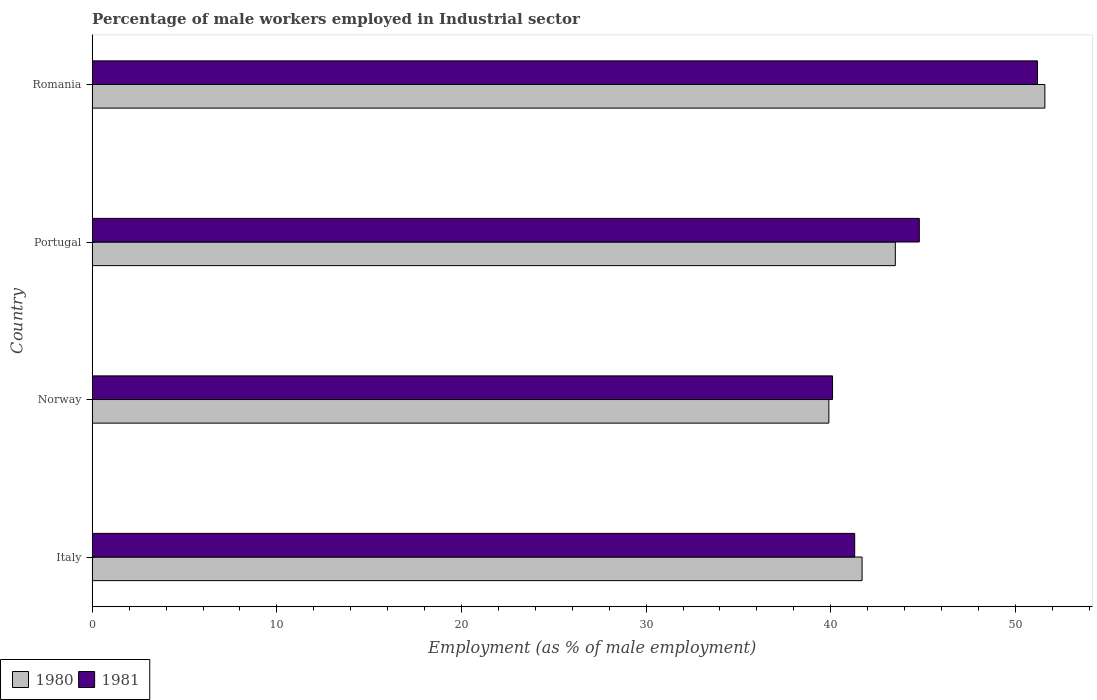How many bars are there on the 1st tick from the top?
Keep it short and to the point. 2. How many bars are there on the 4th tick from the bottom?
Give a very brief answer. 2. What is the label of the 2nd group of bars from the top?
Your response must be concise. Portugal. In how many cases, is the number of bars for a given country not equal to the number of legend labels?
Provide a short and direct response. 0. What is the percentage of male workers employed in Industrial sector in 1981 in Italy?
Your response must be concise. 41.3. Across all countries, what is the maximum percentage of male workers employed in Industrial sector in 1981?
Your answer should be compact. 51.2. Across all countries, what is the minimum percentage of male workers employed in Industrial sector in 1981?
Keep it short and to the point. 40.1. In which country was the percentage of male workers employed in Industrial sector in 1981 maximum?
Offer a terse response. Romania. In which country was the percentage of male workers employed in Industrial sector in 1980 minimum?
Provide a succinct answer. Norway. What is the total percentage of male workers employed in Industrial sector in 1980 in the graph?
Offer a very short reply. 176.7. What is the difference between the percentage of male workers employed in Industrial sector in 1981 in Portugal and that in Romania?
Your answer should be compact. -6.4. What is the average percentage of male workers employed in Industrial sector in 1981 per country?
Your response must be concise. 44.35. What is the difference between the percentage of male workers employed in Industrial sector in 1980 and percentage of male workers employed in Industrial sector in 1981 in Italy?
Provide a short and direct response. 0.4. In how many countries, is the percentage of male workers employed in Industrial sector in 1981 greater than 16 %?
Your answer should be very brief. 4. What is the ratio of the percentage of male workers employed in Industrial sector in 1981 in Italy to that in Romania?
Ensure brevity in your answer.  0.81. Is the percentage of male workers employed in Industrial sector in 1981 in Norway less than that in Romania?
Provide a short and direct response. Yes. What is the difference between the highest and the second highest percentage of male workers employed in Industrial sector in 1980?
Ensure brevity in your answer.  8.1. What is the difference between the highest and the lowest percentage of male workers employed in Industrial sector in 1981?
Your response must be concise. 11.1. Is the sum of the percentage of male workers employed in Industrial sector in 1981 in Norway and Romania greater than the maximum percentage of male workers employed in Industrial sector in 1980 across all countries?
Your answer should be very brief. Yes. What does the 2nd bar from the top in Portugal represents?
Your answer should be very brief. 1980. How many bars are there?
Provide a short and direct response. 8. What is the difference between two consecutive major ticks on the X-axis?
Keep it short and to the point. 10. Are the values on the major ticks of X-axis written in scientific E-notation?
Offer a terse response. No. Where does the legend appear in the graph?
Ensure brevity in your answer.  Bottom left. How many legend labels are there?
Your response must be concise. 2. What is the title of the graph?
Offer a very short reply. Percentage of male workers employed in Industrial sector. What is the label or title of the X-axis?
Ensure brevity in your answer.  Employment (as % of male employment). What is the label or title of the Y-axis?
Provide a short and direct response. Country. What is the Employment (as % of male employment) in 1980 in Italy?
Your response must be concise. 41.7. What is the Employment (as % of male employment) of 1981 in Italy?
Provide a short and direct response. 41.3. What is the Employment (as % of male employment) in 1980 in Norway?
Your answer should be very brief. 39.9. What is the Employment (as % of male employment) of 1981 in Norway?
Give a very brief answer. 40.1. What is the Employment (as % of male employment) of 1980 in Portugal?
Make the answer very short. 43.5. What is the Employment (as % of male employment) of 1981 in Portugal?
Give a very brief answer. 44.8. What is the Employment (as % of male employment) in 1980 in Romania?
Your response must be concise. 51.6. What is the Employment (as % of male employment) of 1981 in Romania?
Make the answer very short. 51.2. Across all countries, what is the maximum Employment (as % of male employment) in 1980?
Give a very brief answer. 51.6. Across all countries, what is the maximum Employment (as % of male employment) in 1981?
Provide a succinct answer. 51.2. Across all countries, what is the minimum Employment (as % of male employment) in 1980?
Offer a terse response. 39.9. Across all countries, what is the minimum Employment (as % of male employment) in 1981?
Offer a very short reply. 40.1. What is the total Employment (as % of male employment) in 1980 in the graph?
Keep it short and to the point. 176.7. What is the total Employment (as % of male employment) of 1981 in the graph?
Offer a very short reply. 177.4. What is the difference between the Employment (as % of male employment) in 1980 in Italy and that in Portugal?
Your response must be concise. -1.8. What is the difference between the Employment (as % of male employment) in 1980 in Italy and that in Romania?
Your answer should be very brief. -9.9. What is the difference between the Employment (as % of male employment) in 1980 in Norway and that in Portugal?
Keep it short and to the point. -3.6. What is the difference between the Employment (as % of male employment) of 1981 in Norway and that in Romania?
Offer a terse response. -11.1. What is the difference between the Employment (as % of male employment) in 1980 in Italy and the Employment (as % of male employment) in 1981 in Portugal?
Your answer should be very brief. -3.1. What is the difference between the Employment (as % of male employment) in 1980 in Norway and the Employment (as % of male employment) in 1981 in Portugal?
Give a very brief answer. -4.9. What is the difference between the Employment (as % of male employment) in 1980 in Portugal and the Employment (as % of male employment) in 1981 in Romania?
Your answer should be compact. -7.7. What is the average Employment (as % of male employment) of 1980 per country?
Your response must be concise. 44.17. What is the average Employment (as % of male employment) in 1981 per country?
Offer a very short reply. 44.35. What is the difference between the Employment (as % of male employment) of 1980 and Employment (as % of male employment) of 1981 in Italy?
Keep it short and to the point. 0.4. What is the difference between the Employment (as % of male employment) in 1980 and Employment (as % of male employment) in 1981 in Romania?
Your answer should be compact. 0.4. What is the ratio of the Employment (as % of male employment) in 1980 in Italy to that in Norway?
Provide a short and direct response. 1.05. What is the ratio of the Employment (as % of male employment) in 1981 in Italy to that in Norway?
Provide a short and direct response. 1.03. What is the ratio of the Employment (as % of male employment) of 1980 in Italy to that in Portugal?
Keep it short and to the point. 0.96. What is the ratio of the Employment (as % of male employment) of 1981 in Italy to that in Portugal?
Offer a very short reply. 0.92. What is the ratio of the Employment (as % of male employment) of 1980 in Italy to that in Romania?
Offer a terse response. 0.81. What is the ratio of the Employment (as % of male employment) in 1981 in Italy to that in Romania?
Provide a short and direct response. 0.81. What is the ratio of the Employment (as % of male employment) of 1980 in Norway to that in Portugal?
Give a very brief answer. 0.92. What is the ratio of the Employment (as % of male employment) of 1981 in Norway to that in Portugal?
Ensure brevity in your answer.  0.9. What is the ratio of the Employment (as % of male employment) of 1980 in Norway to that in Romania?
Make the answer very short. 0.77. What is the ratio of the Employment (as % of male employment) in 1981 in Norway to that in Romania?
Offer a terse response. 0.78. What is the ratio of the Employment (as % of male employment) in 1980 in Portugal to that in Romania?
Make the answer very short. 0.84. What is the ratio of the Employment (as % of male employment) in 1981 in Portugal to that in Romania?
Offer a very short reply. 0.88. What is the difference between the highest and the second highest Employment (as % of male employment) of 1980?
Your response must be concise. 8.1. What is the difference between the highest and the lowest Employment (as % of male employment) of 1981?
Ensure brevity in your answer.  11.1. 